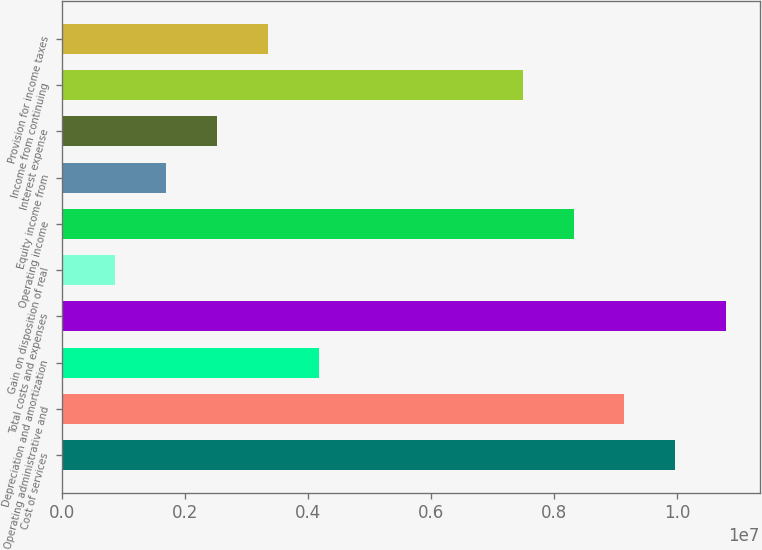Convert chart to OTSL. <chart><loc_0><loc_0><loc_500><loc_500><bar_chart><fcel>Cost of services<fcel>Operating administrative and<fcel>Depreciation and amortization<fcel>Total costs and expenses<fcel>Gain on disposition of real<fcel>Operating income<fcel>Equity income from<fcel>Interest expense<fcel>Income from continuing<fcel>Provision for income taxes<nl><fcel>9.97259e+06<fcel>9.14396e+06<fcel>4.17216e+06<fcel>1.08012e+07<fcel>857632<fcel>8.31532e+06<fcel>1.68626e+06<fcel>2.5149e+06<fcel>7.48669e+06<fcel>3.34353e+06<nl></chart> 